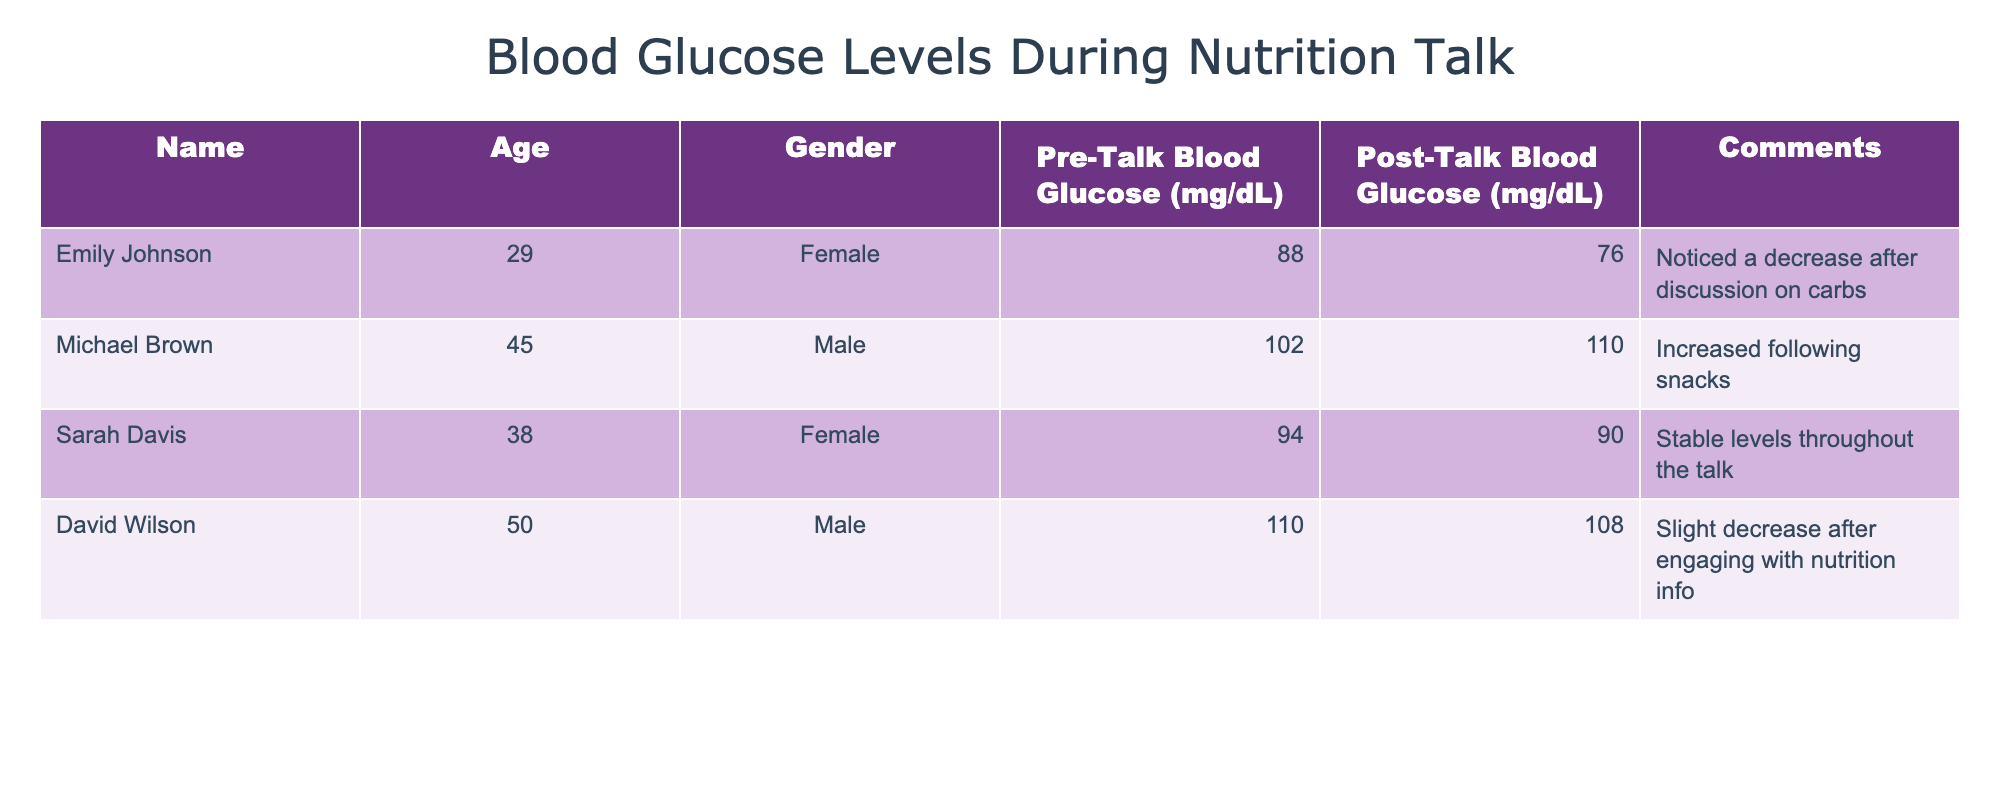What was Emily Johnson's Pre-Talk Blood Glucose level? The table lists Emily Johnson's Pre-Talk Blood Glucose level as 88 mg/dL.
Answer: 88 mg/dL Which attendee had the highest Post-Talk Blood Glucose level? According to the table, Michael Brown had the highest Post-Talk Blood Glucose level at 110 mg/dL.
Answer: 110 mg/dL What is the average Pre-Talk Blood Glucose level for the attendees? The Pre-Talk levels are 88, 102, 94, and 110 mg/dL. Their sum is 394 mg/dL, and there are 4 attendees, so the average is 394/4 = 98.5 mg/dL.
Answer: 98.5 mg/dL Did Sarah Davis's blood glucose levels change from Pre-Talk to Post-Talk? The table shows that Sarah Davis's Pre-Talk level was 94 mg/dL and Post-Talk level was 90 mg/dL, indicating a decrease.
Answer: Yes What is the difference in blood glucose levels for David Wilson from before to after the talk? David Wilson's Pre-Talk level was 110 mg/dL while his Post-Talk level was 108 mg/dL. The difference is 110 - 108 = 2 mg/dL, meaning a slight decrease.
Answer: 2 mg/dL decrease Is it true that both males in the study experienced a change in blood glucose levels after the talk? For males, Michael Brown increased from 102 to 110 mg/dL, while David Wilson decreased from 110 to 108 mg/dL. Thus, there were changes for both.
Answer: Yes What was the overall trend in blood glucose levels for the attendees after the talk? Examining the results: Emily and David decreased, Sarah remained stable, and Michael increased. Therefore, the overall trend shows mixed results with two decreases, one stable, and one increase.
Answer: Mixed results What was the Pre-Talk Blood Glucose level of the oldest attendee? The oldest attendee is David Wilson, with a Pre-Talk Blood Glucose level of 110 mg/dL.
Answer: 110 mg/dL 